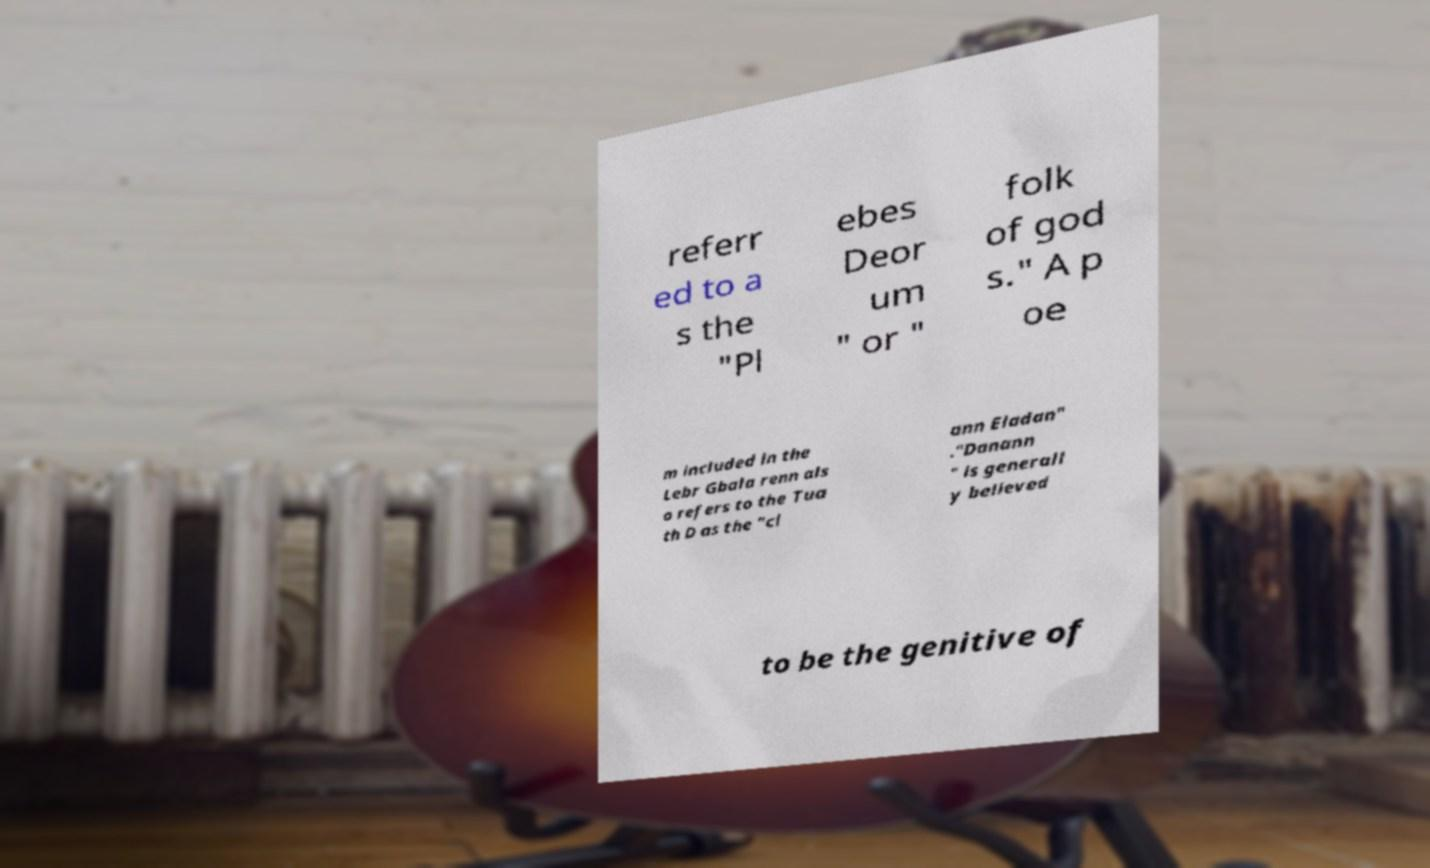I need the written content from this picture converted into text. Can you do that? referr ed to a s the "Pl ebes Deor um " or " folk of god s." A p oe m included in the Lebr Gbala renn als o refers to the Tua th D as the "cl ann Eladan" ."Danann " is generall y believed to be the genitive of 